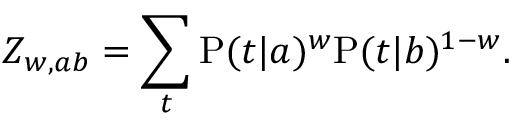<formula> <loc_0><loc_0><loc_500><loc_500>Z _ { w , a b } = \sum _ { t } P ( t | a ) ^ { w } P ( t | b ) ^ { 1 - w } .</formula> 